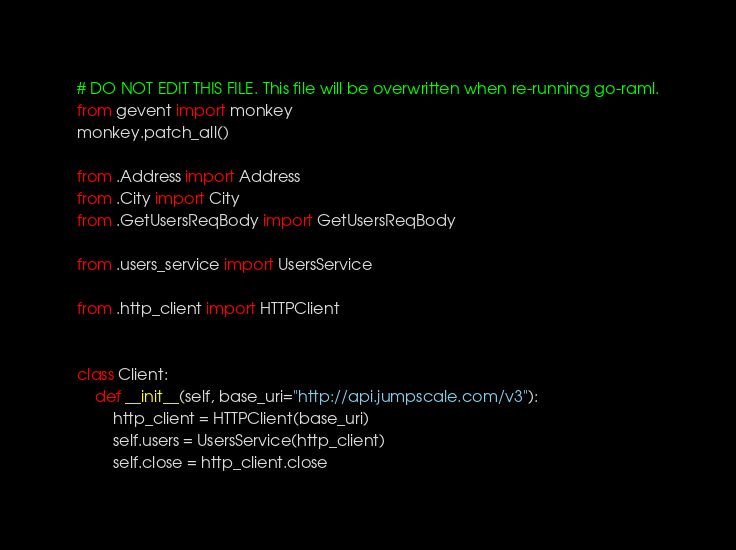Convert code to text. <code><loc_0><loc_0><loc_500><loc_500><_Python_># DO NOT EDIT THIS FILE. This file will be overwritten when re-running go-raml.
from gevent import monkey
monkey.patch_all()

from .Address import Address
from .City import City
from .GetUsersReqBody import GetUsersReqBody

from .users_service import UsersService

from .http_client import HTTPClient


class Client:
    def __init__(self, base_uri="http://api.jumpscale.com/v3"):
        http_client = HTTPClient(base_uri)
        self.users = UsersService(http_client)
        self.close = http_client.close
</code> 